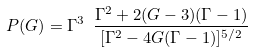<formula> <loc_0><loc_0><loc_500><loc_500>P ( G ) = \Gamma ^ { 3 } \ \frac { \Gamma ^ { 2 } + 2 ( G - 3 ) ( \Gamma - 1 ) } { [ \Gamma ^ { 2 } - 4 G ( \Gamma - 1 ) ] ^ { 5 / 2 } }</formula> 